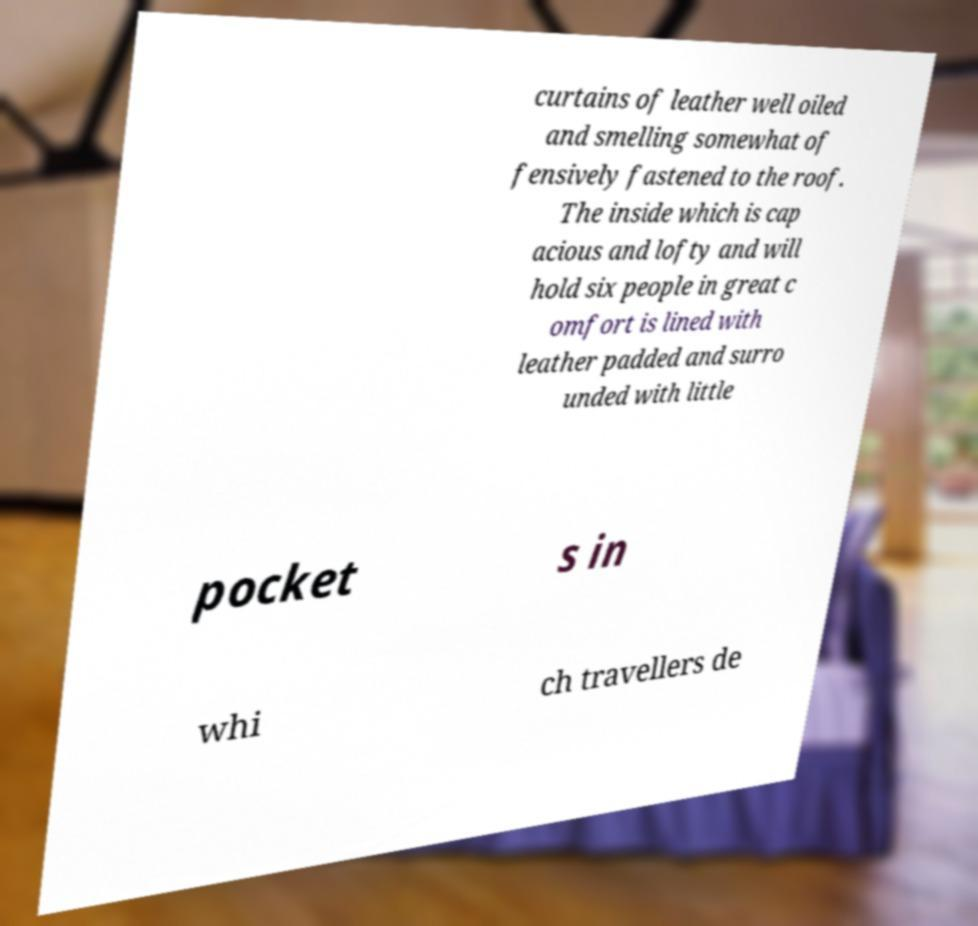Please identify and transcribe the text found in this image. curtains of leather well oiled and smelling somewhat of fensively fastened to the roof. The inside which is cap acious and lofty and will hold six people in great c omfort is lined with leather padded and surro unded with little pocket s in whi ch travellers de 